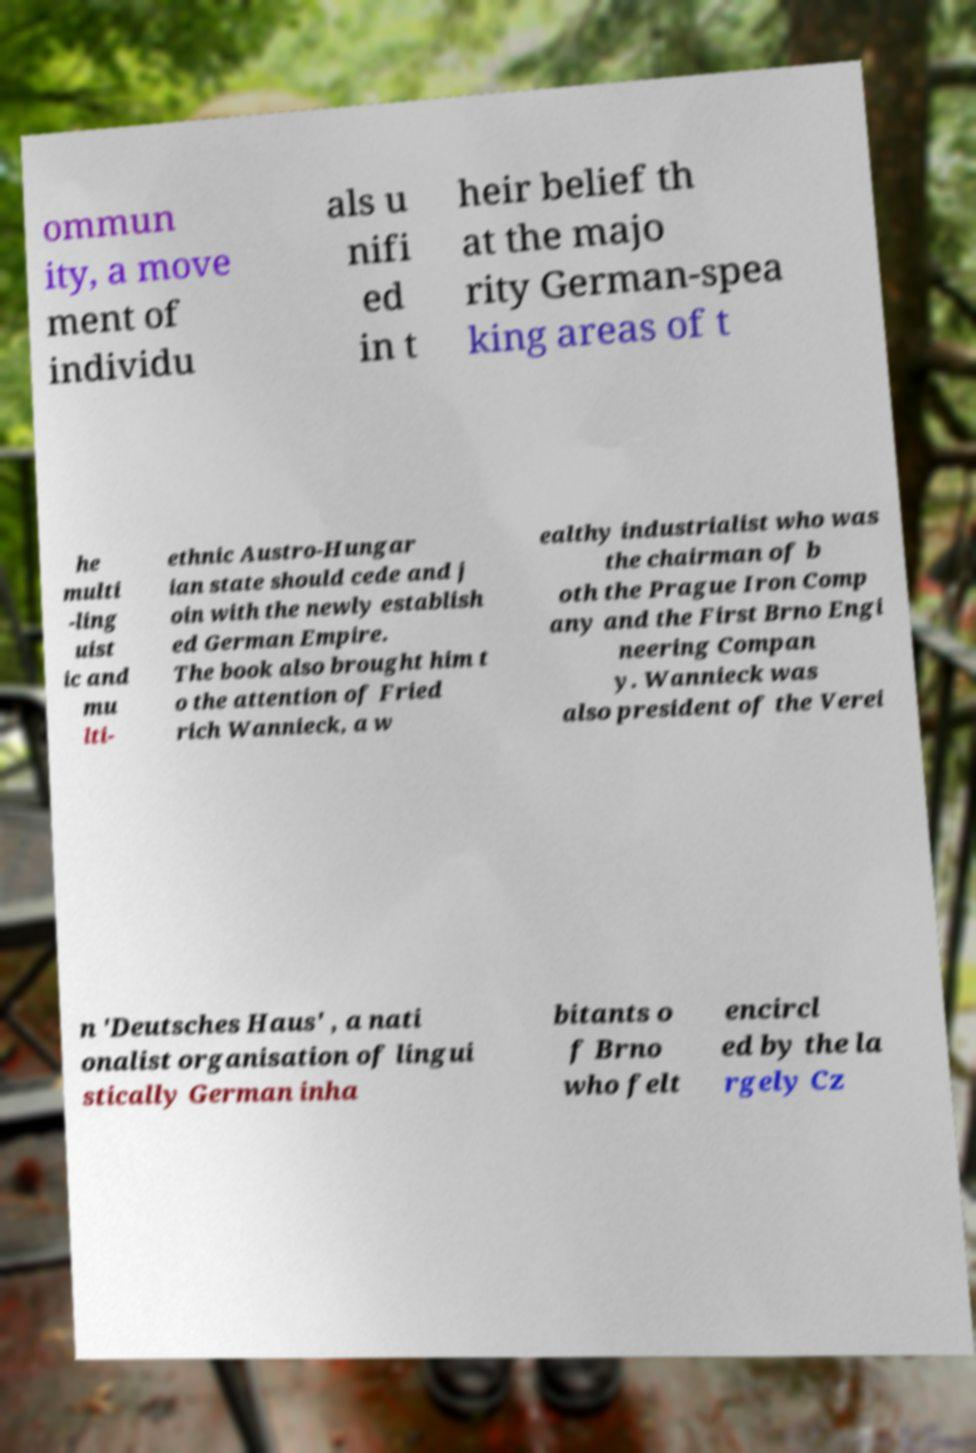Could you extract and type out the text from this image? ommun ity, a move ment of individu als u nifi ed in t heir belief th at the majo rity German-spea king areas of t he multi -ling uist ic and mu lti- ethnic Austro-Hungar ian state should cede and j oin with the newly establish ed German Empire. The book also brought him t o the attention of Fried rich Wannieck, a w ealthy industrialist who was the chairman of b oth the Prague Iron Comp any and the First Brno Engi neering Compan y. Wannieck was also president of the Verei n 'Deutsches Haus' , a nati onalist organisation of lingui stically German inha bitants o f Brno who felt encircl ed by the la rgely Cz 